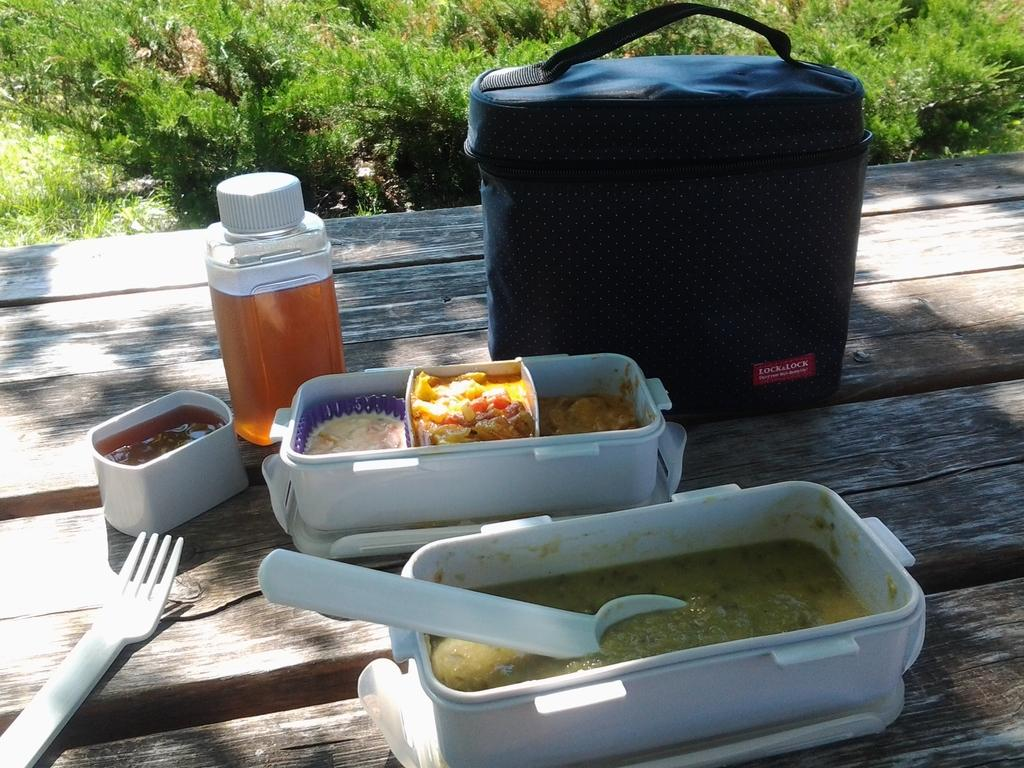<image>
Present a compact description of the photo's key features. Food in white plastic containers and an ice tea on a picnic table with a Lock & Lock cooler next to them. 